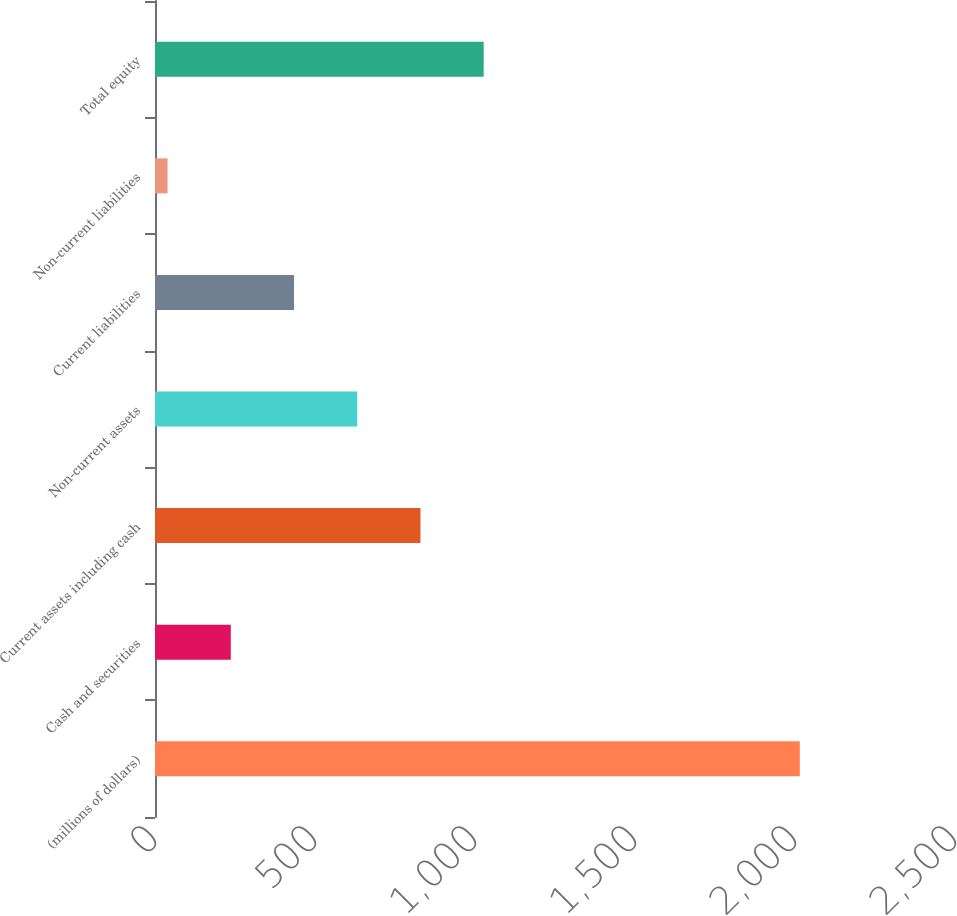Convert chart. <chart><loc_0><loc_0><loc_500><loc_500><bar_chart><fcel>(millions of dollars)<fcel>Cash and securities<fcel>Current assets including cash<fcel>Non-current assets<fcel>Current liabilities<fcel>Non-current liabilities<fcel>Total equity<nl><fcel>2015<fcel>236.87<fcel>829.58<fcel>632.01<fcel>434.44<fcel>39.3<fcel>1027.15<nl></chart> 